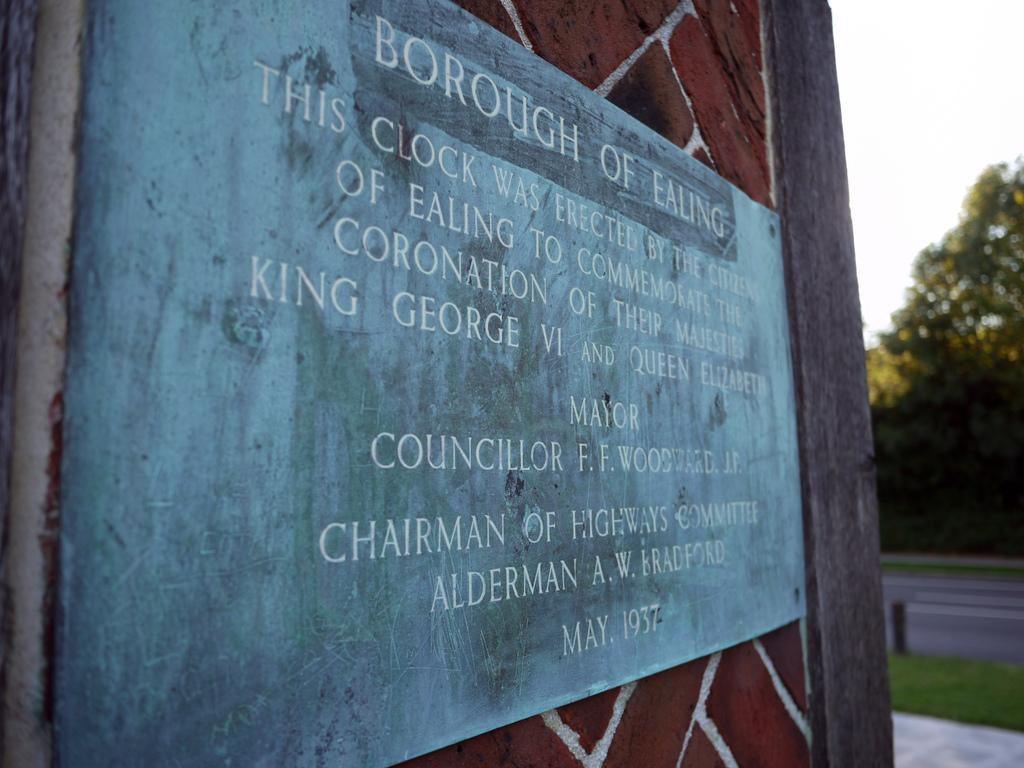<image>
Relay a brief, clear account of the picture shown. A weathered sign lists important people from the past related to the Borough of Ealing. 